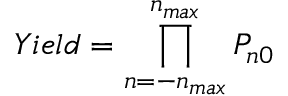<formula> <loc_0><loc_0><loc_500><loc_500>Y i e l d = \prod _ { n = - n _ { \max } } ^ { n _ { \max } } P _ { n 0 }</formula> 